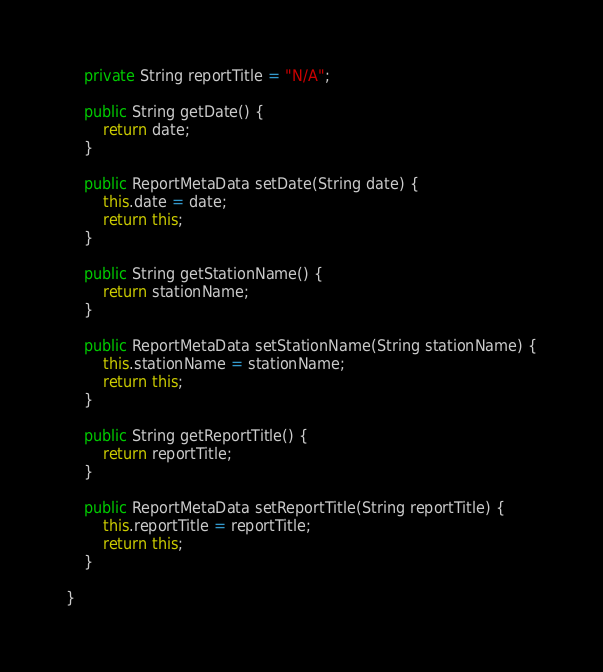Convert code to text. <code><loc_0><loc_0><loc_500><loc_500><_Java_>    private String reportTitle = "N/A";

    public String getDate() {
        return date;
    }

    public ReportMetaData setDate(String date) {
        this.date = date;
        return this;
    }

    public String getStationName() {
        return stationName;
    }

    public ReportMetaData setStationName(String stationName) {
        this.stationName = stationName;
        return this;
    }

    public String getReportTitle() {
        return reportTitle;
    }

    public ReportMetaData setReportTitle(String reportTitle) {
        this.reportTitle = reportTitle;
        return this;
    }

}
</code> 